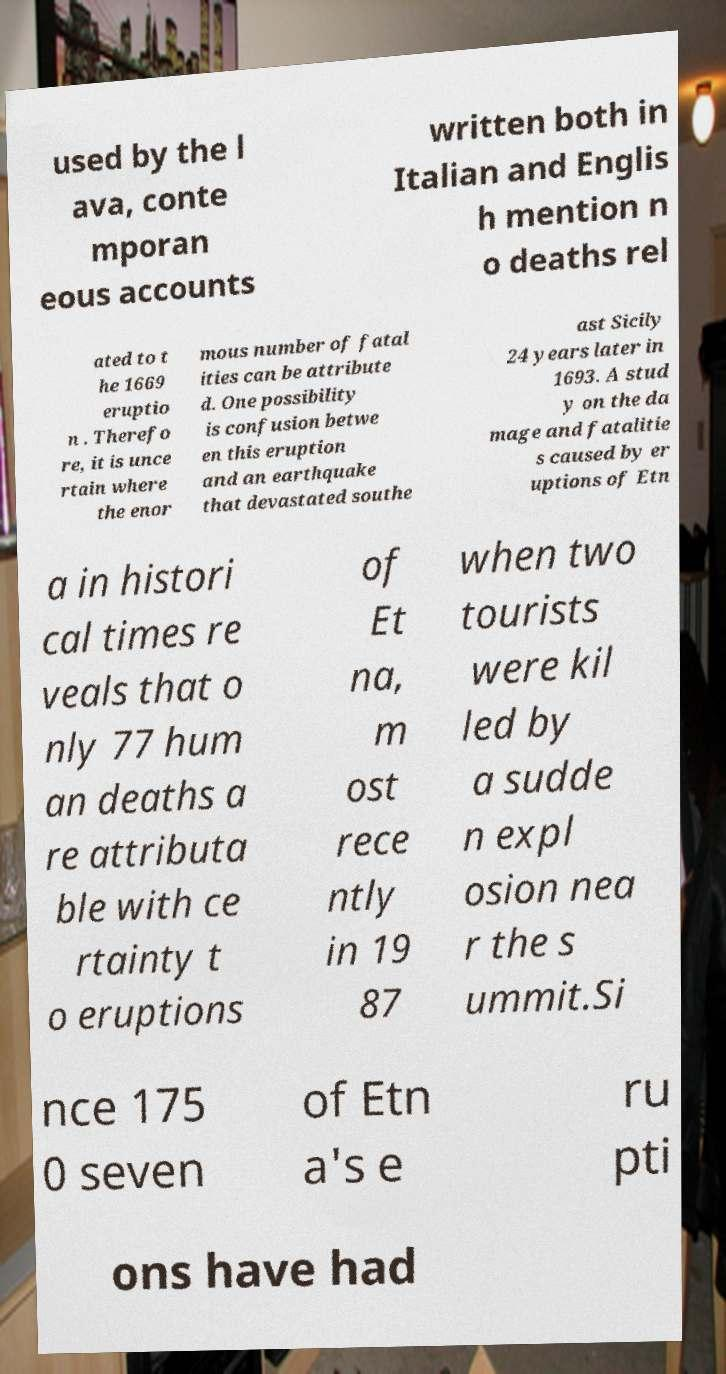What messages or text are displayed in this image? I need them in a readable, typed format. used by the l ava, conte mporan eous accounts written both in Italian and Englis h mention n o deaths rel ated to t he 1669 eruptio n . Therefo re, it is unce rtain where the enor mous number of fatal ities can be attribute d. One possibility is confusion betwe en this eruption and an earthquake that devastated southe ast Sicily 24 years later in 1693. A stud y on the da mage and fatalitie s caused by er uptions of Etn a in histori cal times re veals that o nly 77 hum an deaths a re attributa ble with ce rtainty t o eruptions of Et na, m ost rece ntly in 19 87 when two tourists were kil led by a sudde n expl osion nea r the s ummit.Si nce 175 0 seven of Etn a's e ru pti ons have had 